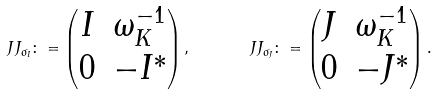Convert formula to latex. <formula><loc_0><loc_0><loc_500><loc_500>\ J J _ { \sigma _ { I } } \colon = \begin{pmatrix} I & \omega _ { K } ^ { - 1 } \\ 0 & - I ^ { * } \end{pmatrix} , \quad \ \ J J _ { \sigma _ { J } } \colon = \begin{pmatrix} J & \omega _ { K } ^ { - 1 } \\ 0 & - J ^ { * } \end{pmatrix} .</formula> 